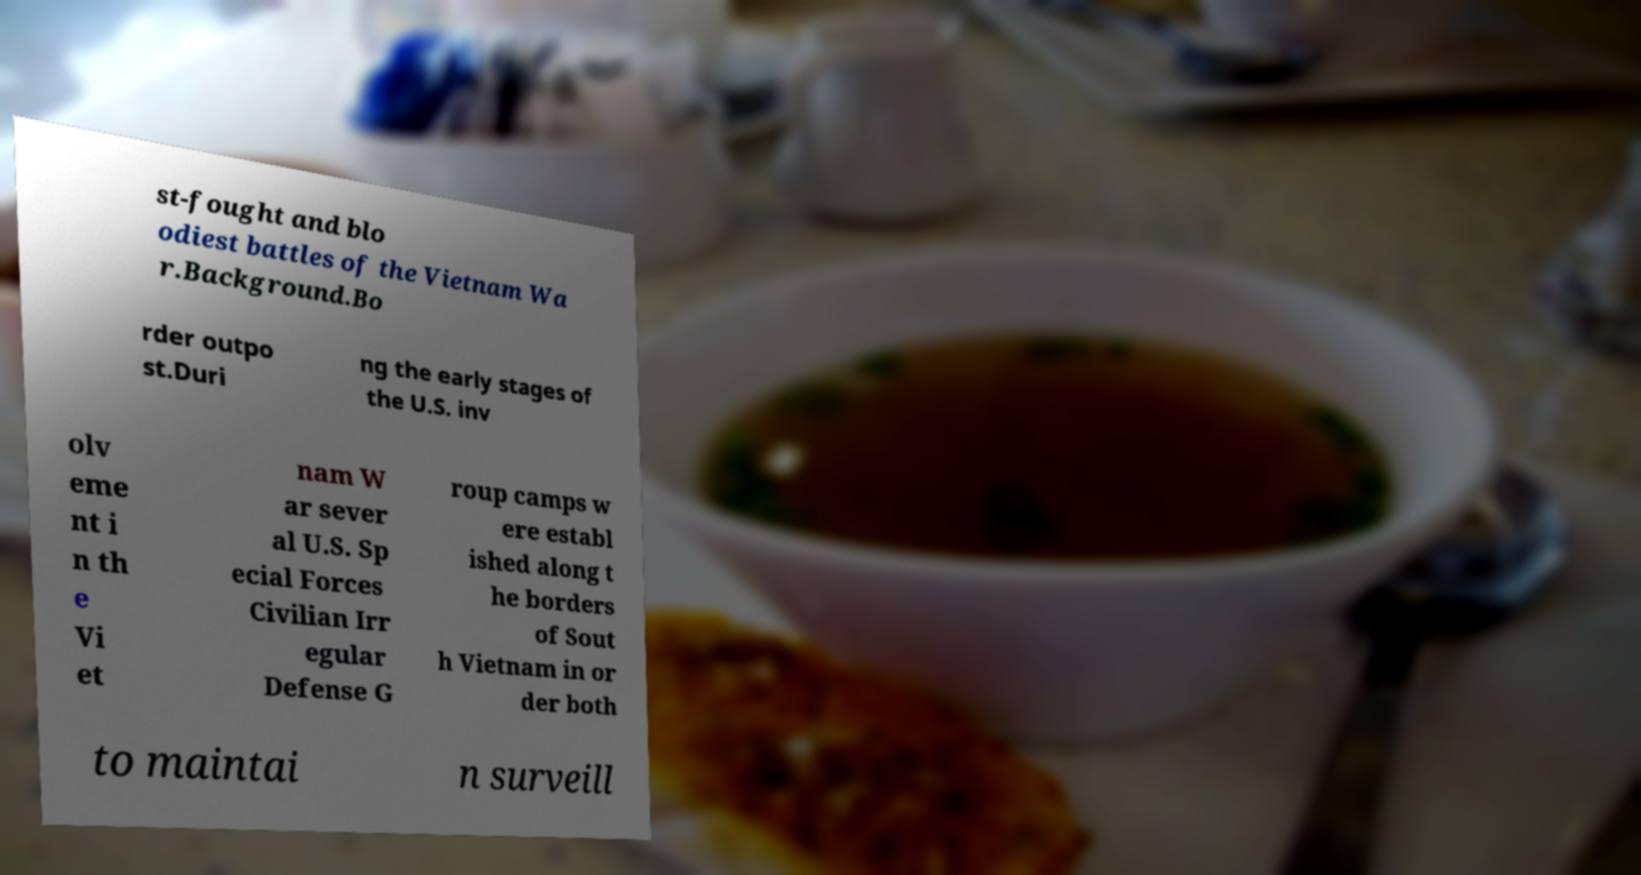I need the written content from this picture converted into text. Can you do that? st-fought and blo odiest battles of the Vietnam Wa r.Background.Bo rder outpo st.Duri ng the early stages of the U.S. inv olv eme nt i n th e Vi et nam W ar sever al U.S. Sp ecial Forces Civilian Irr egular Defense G roup camps w ere establ ished along t he borders of Sout h Vietnam in or der both to maintai n surveill 